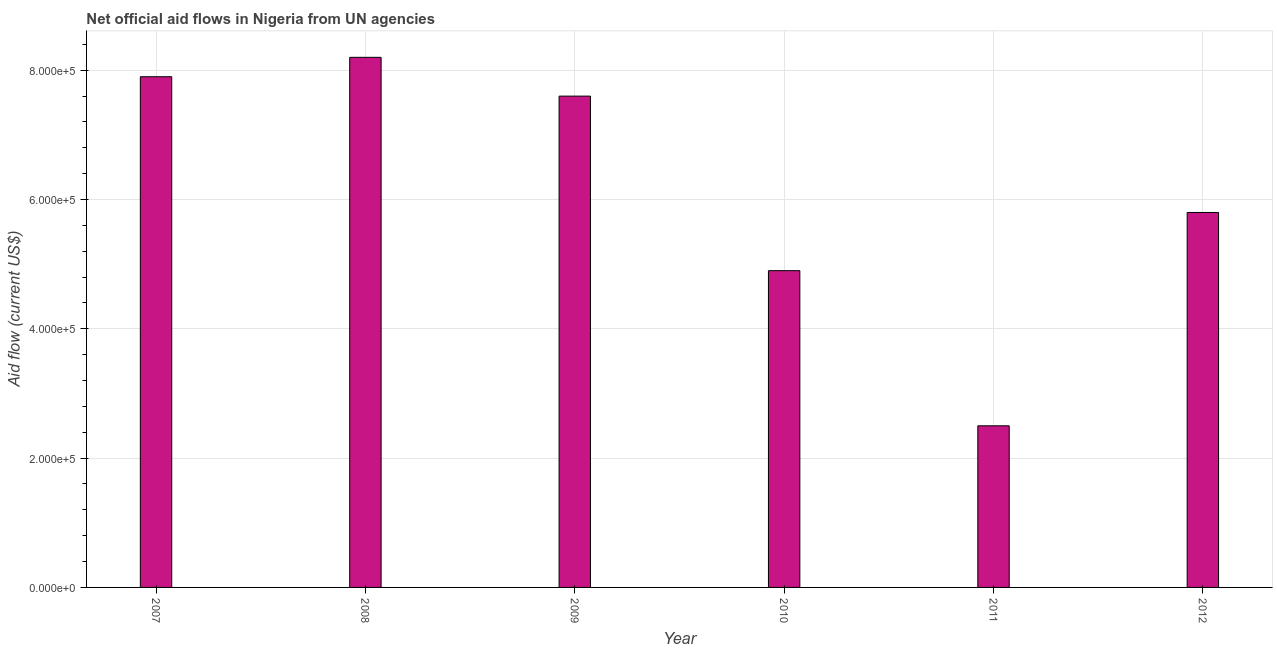What is the title of the graph?
Provide a succinct answer. Net official aid flows in Nigeria from UN agencies. What is the label or title of the X-axis?
Make the answer very short. Year. What is the net official flows from un agencies in 2010?
Your response must be concise. 4.90e+05. Across all years, what is the maximum net official flows from un agencies?
Offer a very short reply. 8.20e+05. In which year was the net official flows from un agencies maximum?
Ensure brevity in your answer.  2008. In which year was the net official flows from un agencies minimum?
Give a very brief answer. 2011. What is the sum of the net official flows from un agencies?
Ensure brevity in your answer.  3.69e+06. What is the difference between the net official flows from un agencies in 2008 and 2009?
Offer a very short reply. 6.00e+04. What is the average net official flows from un agencies per year?
Provide a short and direct response. 6.15e+05. What is the median net official flows from un agencies?
Make the answer very short. 6.70e+05. In how many years, is the net official flows from un agencies greater than 400000 US$?
Ensure brevity in your answer.  5. Do a majority of the years between 2009 and 2012 (inclusive) have net official flows from un agencies greater than 720000 US$?
Ensure brevity in your answer.  No. What is the ratio of the net official flows from un agencies in 2008 to that in 2010?
Keep it short and to the point. 1.67. Is the net official flows from un agencies in 2008 less than that in 2010?
Offer a terse response. No. Is the sum of the net official flows from un agencies in 2011 and 2012 greater than the maximum net official flows from un agencies across all years?
Offer a very short reply. Yes. What is the difference between the highest and the lowest net official flows from un agencies?
Provide a succinct answer. 5.70e+05. In how many years, is the net official flows from un agencies greater than the average net official flows from un agencies taken over all years?
Give a very brief answer. 3. How many bars are there?
Provide a succinct answer. 6. Are all the bars in the graph horizontal?
Make the answer very short. No. How many years are there in the graph?
Ensure brevity in your answer.  6. What is the difference between two consecutive major ticks on the Y-axis?
Your answer should be compact. 2.00e+05. What is the Aid flow (current US$) in 2007?
Keep it short and to the point. 7.90e+05. What is the Aid flow (current US$) of 2008?
Give a very brief answer. 8.20e+05. What is the Aid flow (current US$) in 2009?
Keep it short and to the point. 7.60e+05. What is the Aid flow (current US$) in 2012?
Your response must be concise. 5.80e+05. What is the difference between the Aid flow (current US$) in 2007 and 2009?
Your answer should be compact. 3.00e+04. What is the difference between the Aid flow (current US$) in 2007 and 2010?
Your answer should be very brief. 3.00e+05. What is the difference between the Aid flow (current US$) in 2007 and 2011?
Offer a terse response. 5.40e+05. What is the difference between the Aid flow (current US$) in 2008 and 2010?
Provide a succinct answer. 3.30e+05. What is the difference between the Aid flow (current US$) in 2008 and 2011?
Provide a short and direct response. 5.70e+05. What is the difference between the Aid flow (current US$) in 2009 and 2010?
Ensure brevity in your answer.  2.70e+05. What is the difference between the Aid flow (current US$) in 2009 and 2011?
Your answer should be compact. 5.10e+05. What is the difference between the Aid flow (current US$) in 2010 and 2011?
Offer a terse response. 2.40e+05. What is the difference between the Aid flow (current US$) in 2011 and 2012?
Your answer should be very brief. -3.30e+05. What is the ratio of the Aid flow (current US$) in 2007 to that in 2009?
Your answer should be compact. 1.04. What is the ratio of the Aid flow (current US$) in 2007 to that in 2010?
Offer a very short reply. 1.61. What is the ratio of the Aid flow (current US$) in 2007 to that in 2011?
Your answer should be compact. 3.16. What is the ratio of the Aid flow (current US$) in 2007 to that in 2012?
Your response must be concise. 1.36. What is the ratio of the Aid flow (current US$) in 2008 to that in 2009?
Offer a terse response. 1.08. What is the ratio of the Aid flow (current US$) in 2008 to that in 2010?
Offer a terse response. 1.67. What is the ratio of the Aid flow (current US$) in 2008 to that in 2011?
Your response must be concise. 3.28. What is the ratio of the Aid flow (current US$) in 2008 to that in 2012?
Provide a succinct answer. 1.41. What is the ratio of the Aid flow (current US$) in 2009 to that in 2010?
Offer a terse response. 1.55. What is the ratio of the Aid flow (current US$) in 2009 to that in 2011?
Ensure brevity in your answer.  3.04. What is the ratio of the Aid flow (current US$) in 2009 to that in 2012?
Provide a short and direct response. 1.31. What is the ratio of the Aid flow (current US$) in 2010 to that in 2011?
Make the answer very short. 1.96. What is the ratio of the Aid flow (current US$) in 2010 to that in 2012?
Your answer should be compact. 0.84. What is the ratio of the Aid flow (current US$) in 2011 to that in 2012?
Ensure brevity in your answer.  0.43. 